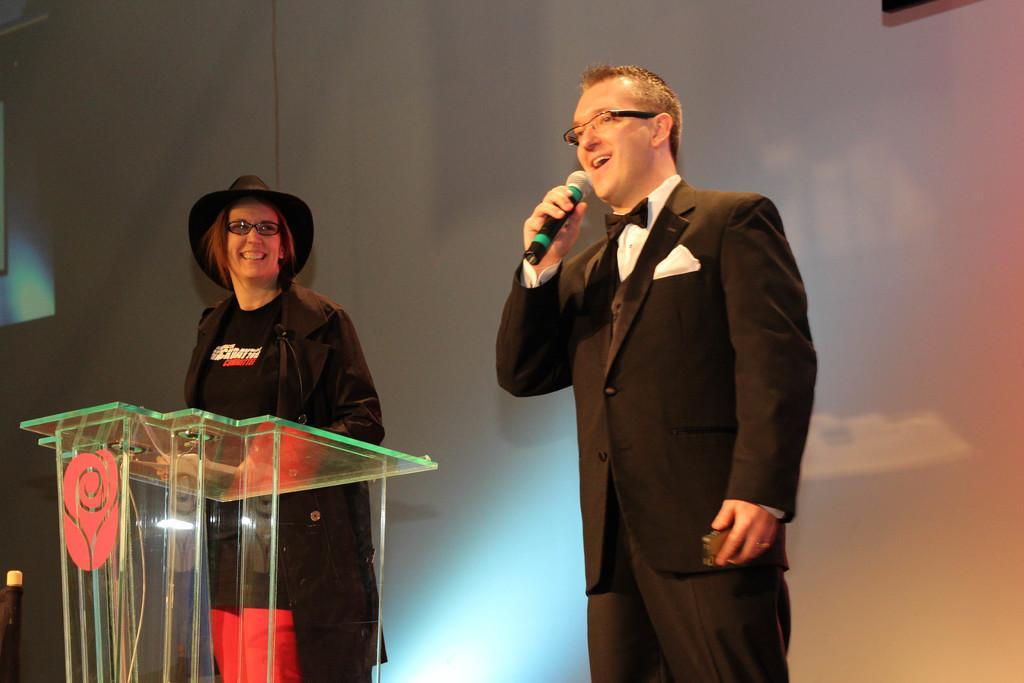Can you describe this image briefly? In this image we can see a man. He is wearing a suit and he is speaking on a microphone. Here we can see the glass podium on the left side. Here we can see a woman on the left side and there is a smile on her face. 